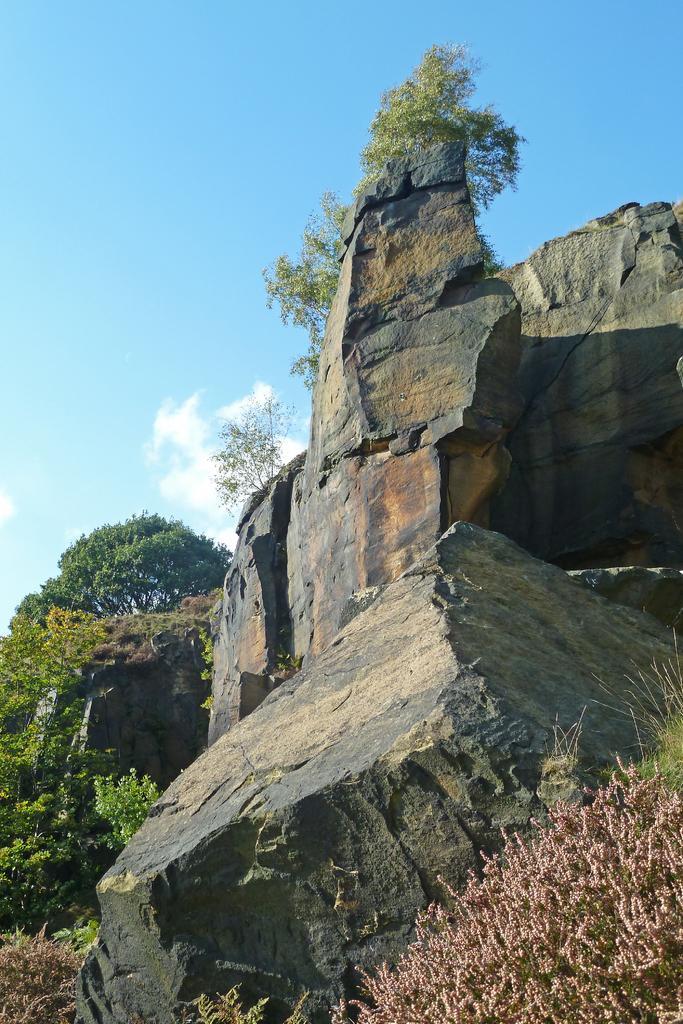Can you describe this image briefly? On the right side we can see rocks and at the bottom corner there is a plant. In the background there are trees,rocks,plants and clouds in the sky. 